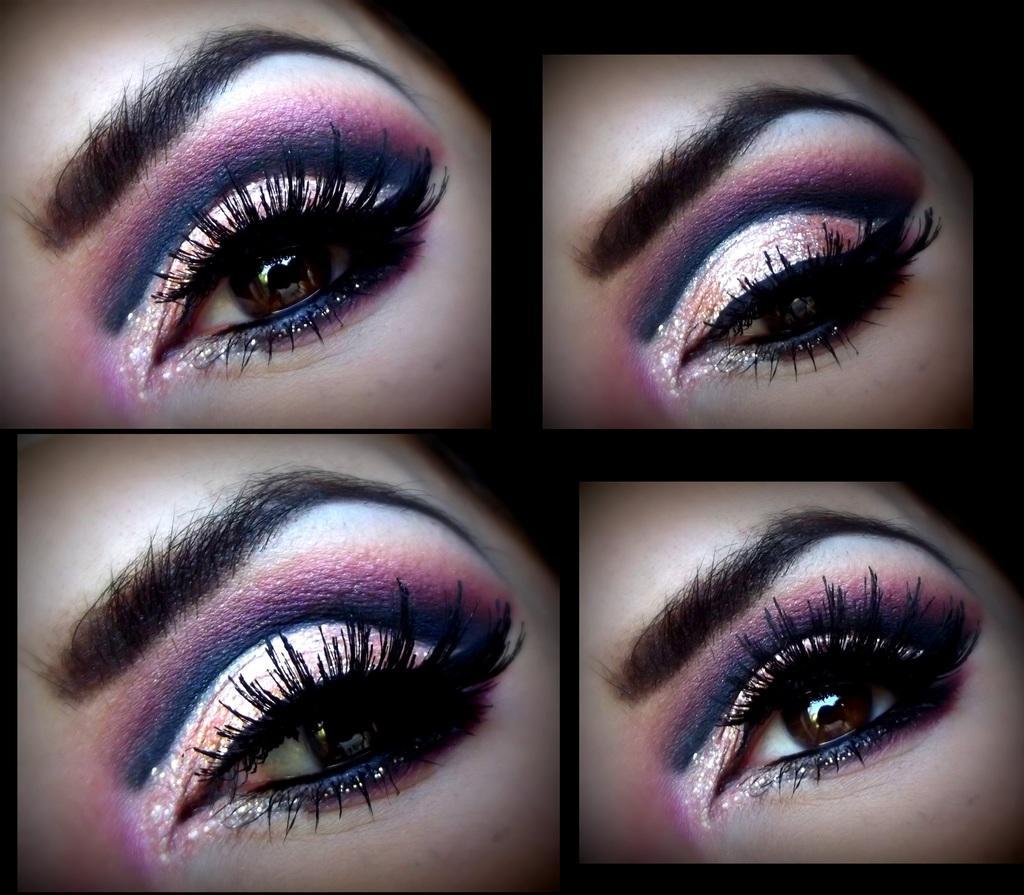In one or two sentences, can you explain what this image depicts? In this image we can see the eyes. We can see the collage photo. 